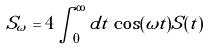<formula> <loc_0><loc_0><loc_500><loc_500>S _ { \omega } = 4 \int _ { 0 } ^ { \infty } d t \, \cos ( \omega t ) S ( t )</formula> 